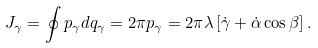<formula> <loc_0><loc_0><loc_500><loc_500>J _ { \gamma } = \oint p _ { \gamma } d q _ { \gamma } = 2 \pi p _ { \gamma } = 2 \pi \lambda \left [ \dot { \gamma } + \dot { \alpha } \cos \beta \right ] .</formula> 